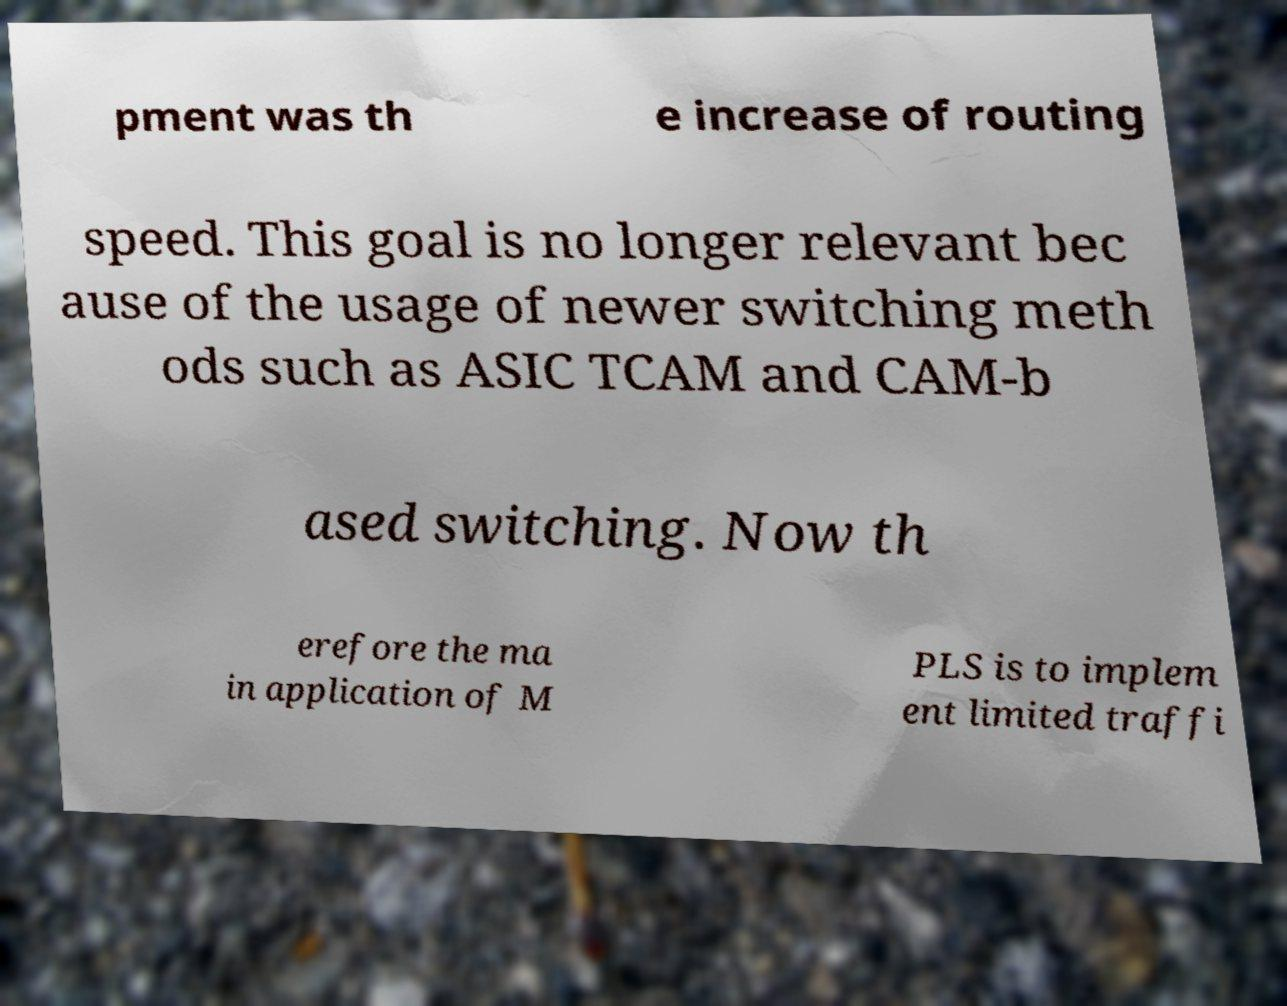Can you read and provide the text displayed in the image?This photo seems to have some interesting text. Can you extract and type it out for me? pment was th e increase of routing speed. This goal is no longer relevant bec ause of the usage of newer switching meth ods such as ASIC TCAM and CAM-b ased switching. Now th erefore the ma in application of M PLS is to implem ent limited traffi 